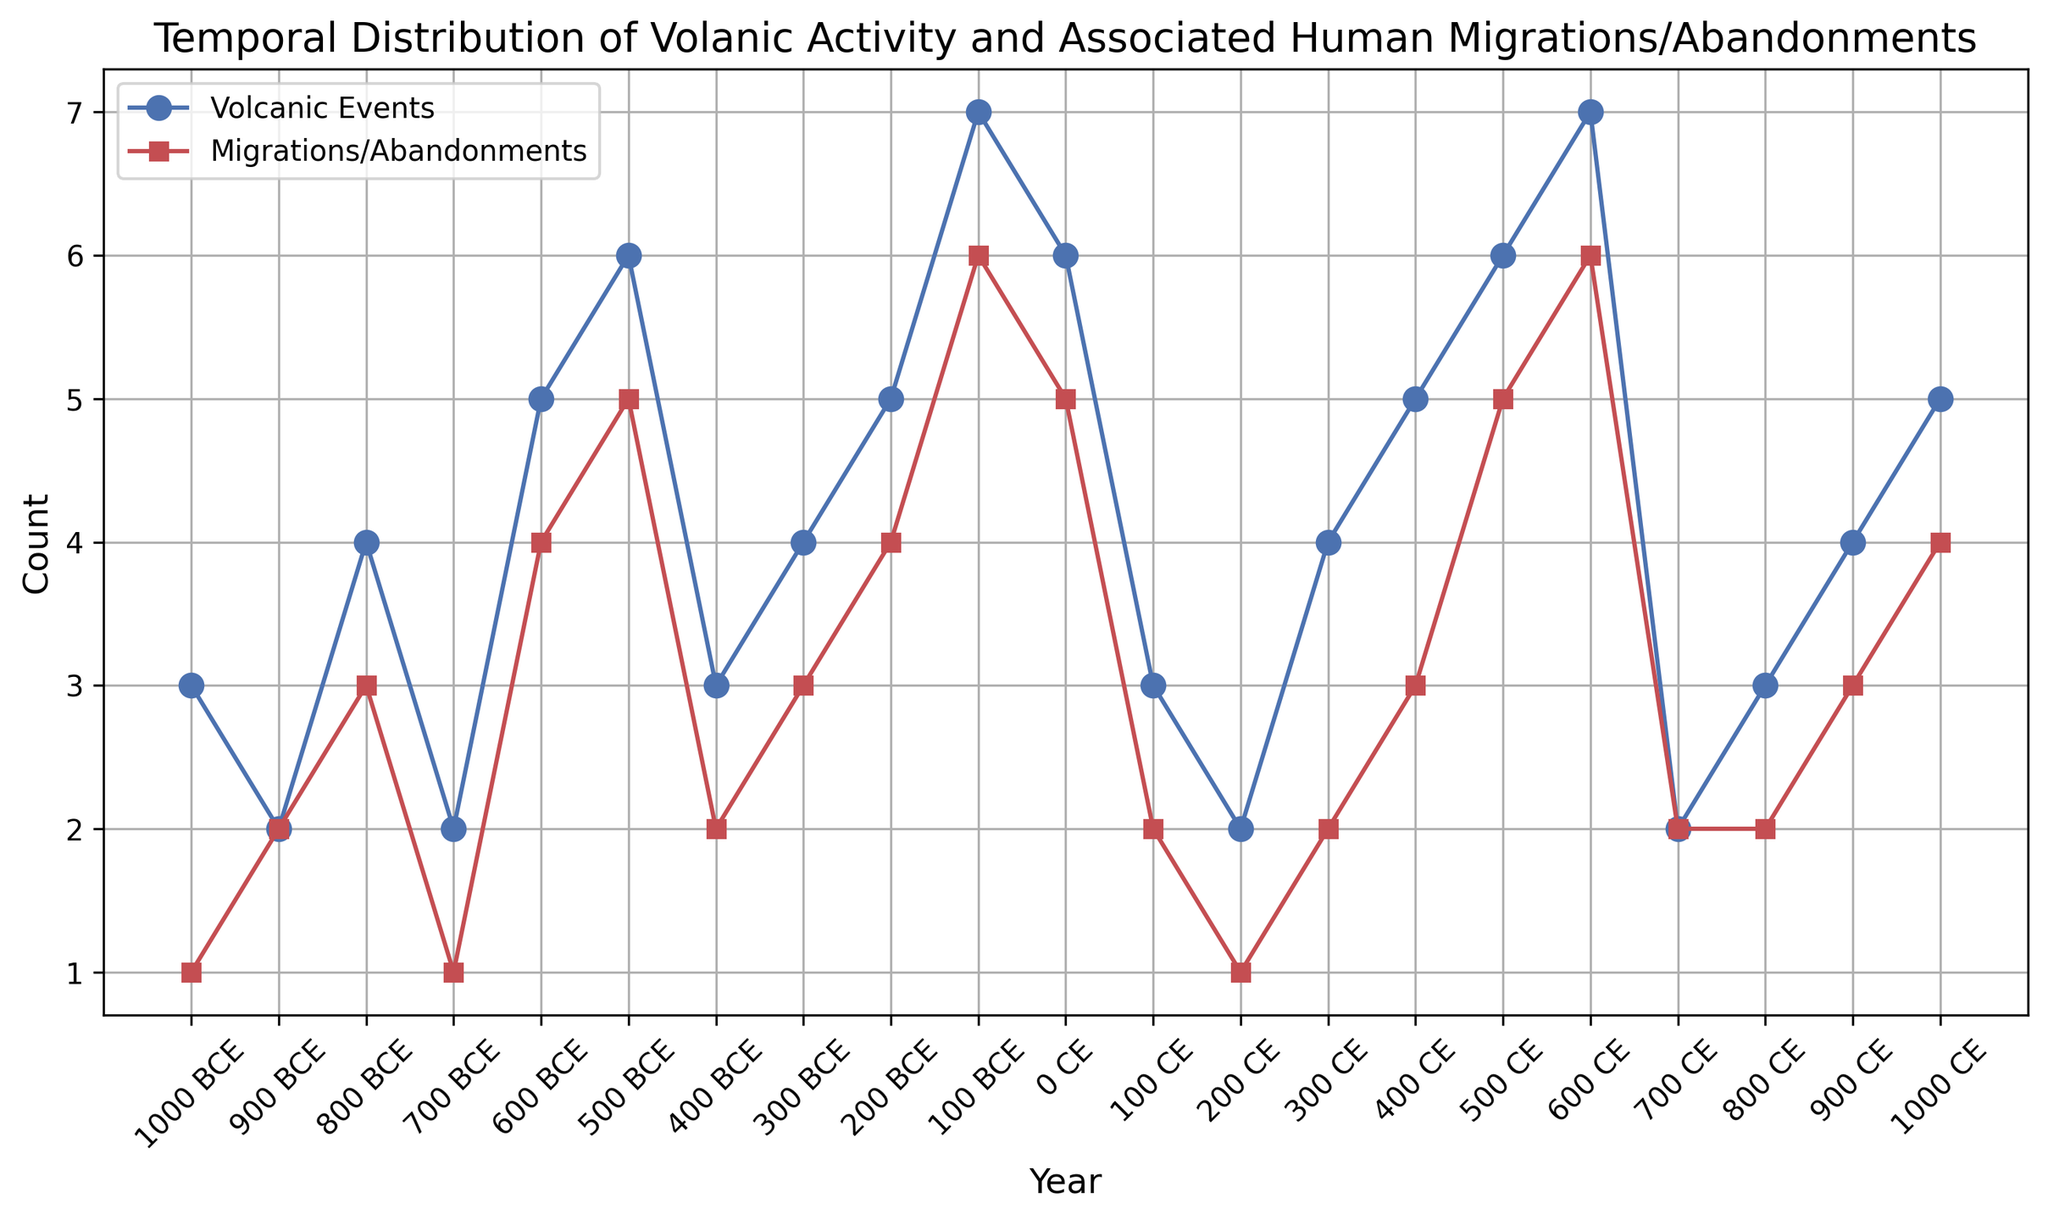What year had the highest number of volcanic events? Look at the line indicating volcanic events. The highest point on this line corresponds to the year label at the x-axis. The highest value is 7, which occurs at two points: 100 BCE and 600 CE.
Answer: 100 BCE and 600 CE In which year did both volcanic events and migrations/abandonments have a value of 6? Check the values on both lines for volcanic events (blue) and migrations/abandonments (red). Identify the year where both lines reach a value of 6.
Answer: 100 BCE and 600 CE What is the overall trend in volcanic activity from 1000 BCE to 1000 CE? Observe the line for volcanic events from the start to the end. The trend shows fluctuations with an overall gradual increase toward the later years.
Answer: Gradually increasing with fluctuations How does the number of migrations/abandonments in 0 CE compare to that in 500 CE? Look at the migration/abandonments values at 0 CE and 500 CE on the red line. Compare the positions of these points. Both values are equal to 5.
Answer: Equal What is the difference in the number of volcanic events between 200 BCE and 100 BCE? Find the number of volcanic events at 200 BCE and 100 BCE. Do the subtraction to find the difference. The values are 5 and 7, respectively. The difference is 7 - 5.
Answer: 2 In which centuries did the number of volcanic events exceed 6? Identify the years in which the volcanic events line exceeds a value of 6. These occur around 100 BCE and 600 CE, which are in the 1st century BCE and 6th century CE.
Answer: 1st century BCE and 6th century CE When did migrations/abandonments first reach the value of 4? Trace the line representing migrations/abandonments to find the earliest year at which it reaches 4. The first occurrence is in 600 BCE.
Answer: 600 BCE What is the average number of volcanic events between 400 BCE and 0 CE? Identify the volcanic events from 400 BCE to 0 CE: [3, 4, 5, 7, 6]. Sum these values and divide by the number of points. (3+4+5+7+6) / 5.
Answer: 5 Which color in the plot represents volcanic events? Observing the lines in the plot, the volcanic events line is depicted in blue.
Answer: Blue During which period did volcanic events and migrations/abandonments show the closest values? Compare the values of volcanic events and migrations/abandonments at each year. Close values occur at multiple years, such as 900 BCE (2 and 2), 200 BCE (5 and 4), and more.
Answer: Multiple years like 900 BCE & 200 BCE 